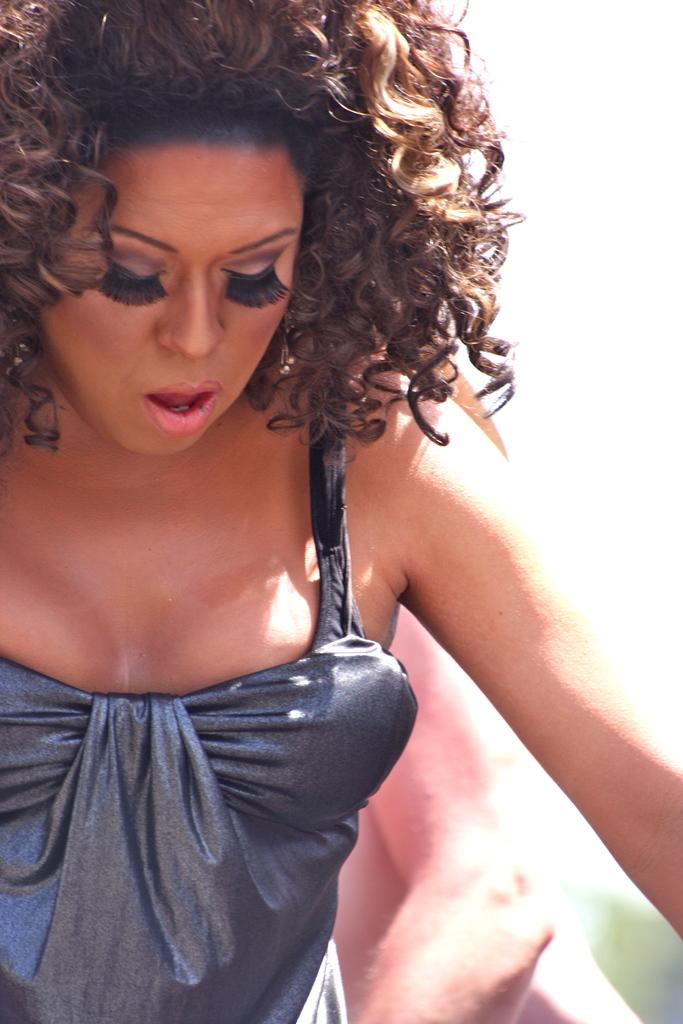How many people are in the image? There are two persons in the image. What is the color of the dress worn by one of the persons? One person is wearing a gray dress. What is the color of the background in the image? The background of the image is white. What type of lumber can be seen near the coast in the image? There is no lumber or coast present in the image; it features two persons and a white background. Is there a judge visible in the image? There is no judge present in the image. 